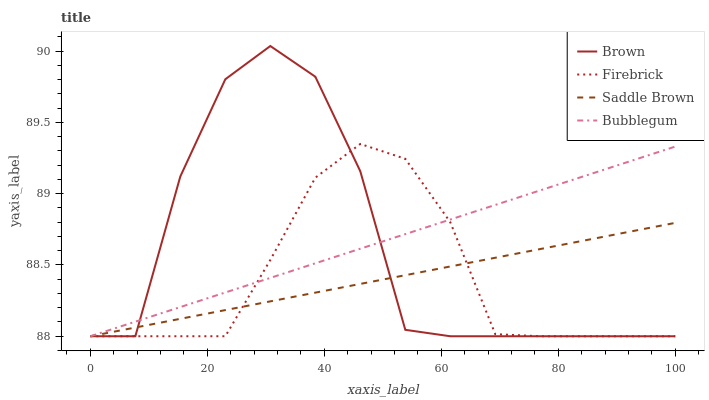Does Firebrick have the minimum area under the curve?
Answer yes or no. Yes. Does Bubblegum have the maximum area under the curve?
Answer yes or no. Yes. Does Saddle Brown have the minimum area under the curve?
Answer yes or no. No. Does Saddle Brown have the maximum area under the curve?
Answer yes or no. No. Is Saddle Brown the smoothest?
Answer yes or no. Yes. Is Brown the roughest?
Answer yes or no. Yes. Is Firebrick the smoothest?
Answer yes or no. No. Is Firebrick the roughest?
Answer yes or no. No. Does Brown have the lowest value?
Answer yes or no. Yes. Does Brown have the highest value?
Answer yes or no. Yes. Does Firebrick have the highest value?
Answer yes or no. No. Does Brown intersect Saddle Brown?
Answer yes or no. Yes. Is Brown less than Saddle Brown?
Answer yes or no. No. Is Brown greater than Saddle Brown?
Answer yes or no. No. 